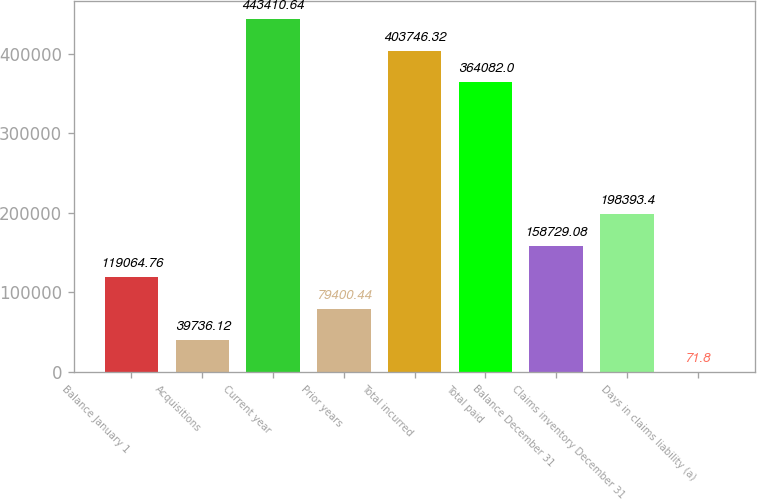<chart> <loc_0><loc_0><loc_500><loc_500><bar_chart><fcel>Balance January 1<fcel>Acquisitions<fcel>Current year<fcel>Prior years<fcel>Total incurred<fcel>Total paid<fcel>Balance December 31<fcel>Claims inventory December 31<fcel>Days in claims liability (a)<nl><fcel>119065<fcel>39736.1<fcel>443411<fcel>79400.4<fcel>403746<fcel>364082<fcel>158729<fcel>198393<fcel>71.8<nl></chart> 